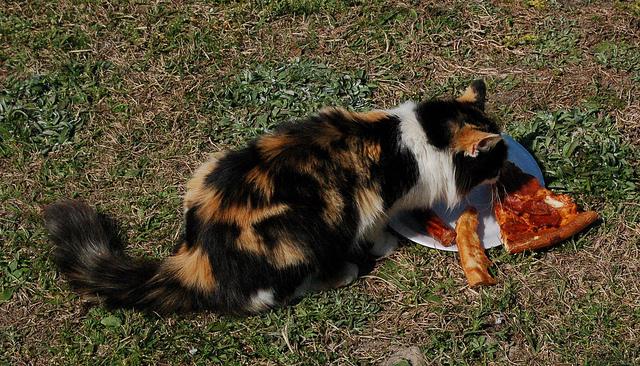How many animals?
Answer briefly. 1. What is the cat eating?
Quick response, please. Pizza. What is the cat doing?
Write a very short answer. Eating. Where is the food?
Give a very brief answer. On plate. 